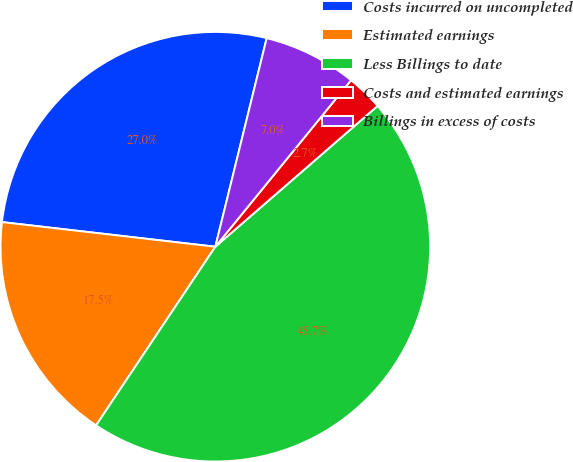<chart> <loc_0><loc_0><loc_500><loc_500><pie_chart><fcel>Costs incurred on uncompleted<fcel>Estimated earnings<fcel>Less Billings to date<fcel>Costs and estimated earnings<fcel>Billings in excess of costs<nl><fcel>27.01%<fcel>17.46%<fcel>45.74%<fcel>2.74%<fcel>7.04%<nl></chart> 